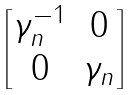Convert formula to latex. <formula><loc_0><loc_0><loc_500><loc_500>\begin{bmatrix} \gamma _ { n } ^ { - 1 } & 0 \\ 0 & \gamma _ { n } \end{bmatrix}</formula> 